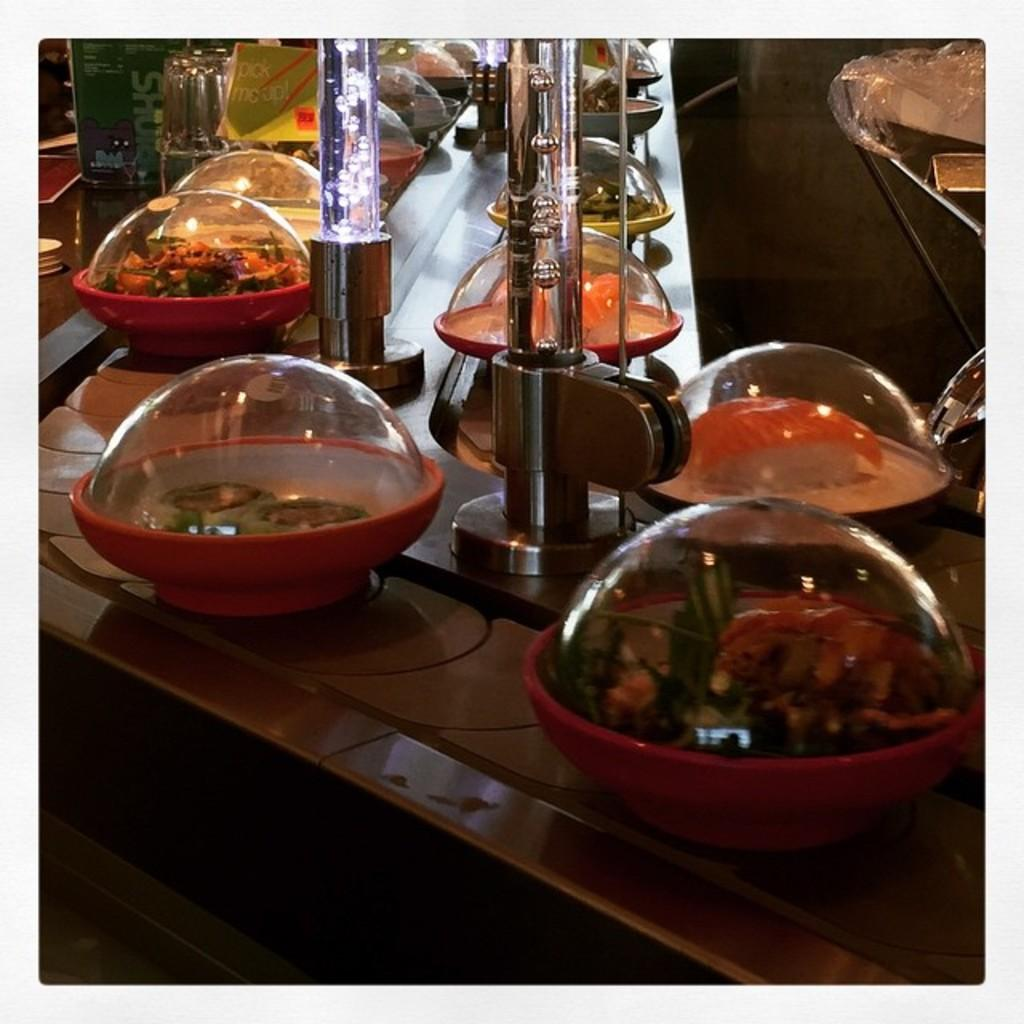What objects can be seen on the table in the image? There are dishes and glass tubes on the table in the image. Can you describe the dishes in the image? Unfortunately, the facts provided do not give any details about the dishes. What can you tell me about the glass tubes in the image? The facts provided do not give any details about the glass tubes. Where is the secretary sitting in the image? There is no secretary present in the image. Can you see any steam coming from the dishes in the image? The facts provided do not mention any steam in the image. Are there any sheep visible in the image? There are no sheep present in the image. 